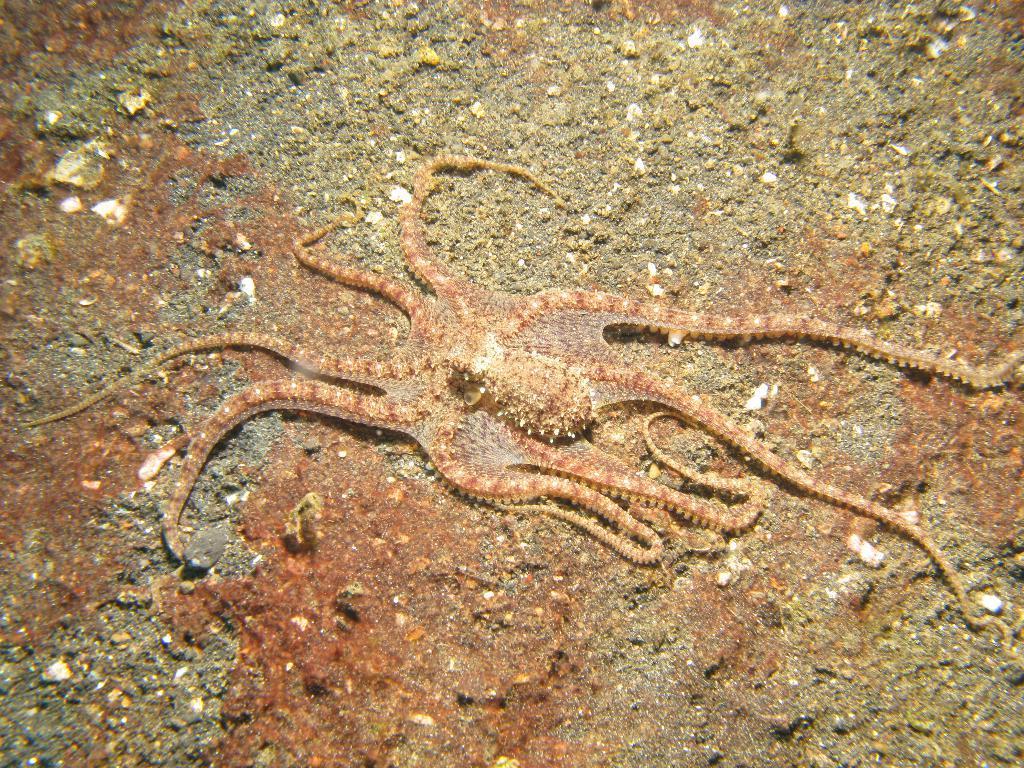Could you give a brief overview of what you see in this image? In this picture we can see an octopus on the path. 